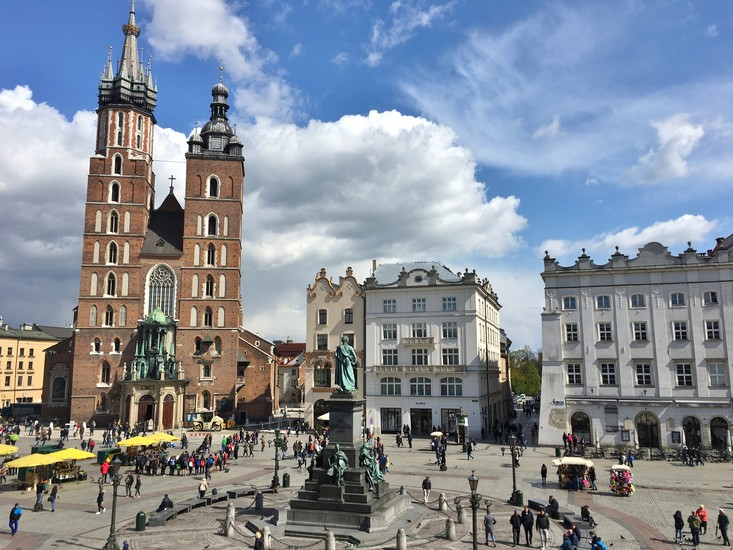Imagine and elaborate a mythical story inspired by the history and architecture of this square. In an age long forgotten, the Main Market Square of Krakow was known as the Crossroads of Realms. Each night, under the cover of darkness, the towering spires of St. Mary's Basilica would resonate with a magical hum, opening a portal to a mystical world. The square would transform, its cobblestones glowing with ancient runes, revealing hidden pathways to lands of dragons, fairies, and sorcery.

Legend tells of a young poet, much like Adam Mickiewicz, who, guided by the spirit etched in the bronze statue, ventured through the portal on a quest to save his city from a looming shadow. Carrying a quill enchanted with the fire of a dragon's breath, he wrote spells in the air, weaving them into the fabric of reality. His journey took him through enchanted forests, across seas of stardust, and into the very heart of the dragon's lair.

With wisdom and bravery, he brokered peace with the ancient dragon, who, in return for his freedom, gifted Krakow a crystal orb that kept the city in eternal prosperity. To this day, on certain full moon nights, whispers on the wind echo through the square, hinting at the hidden magic of the Crossroads of Realms, waiting to be reawakened by a pure heart and a courageous spirit. 